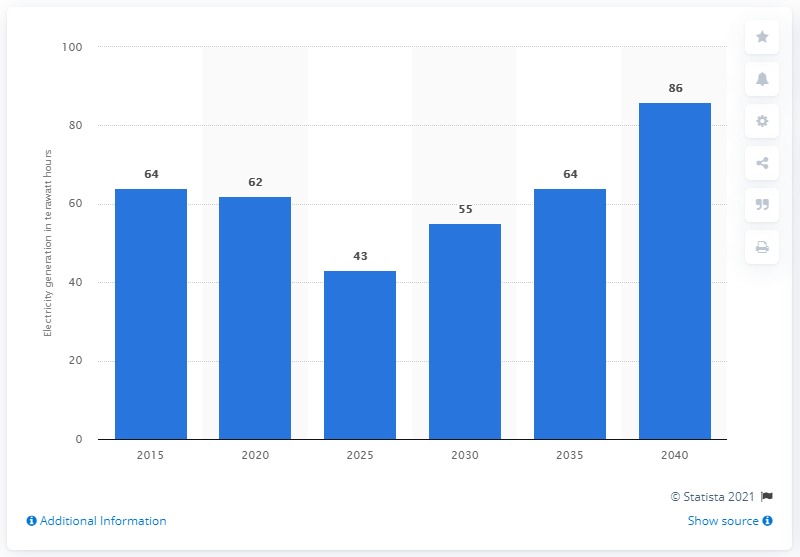Highlight a few significant elements in this photo. In 2025, the UK's nuclear power generation is forecasted to reach a historic low. 